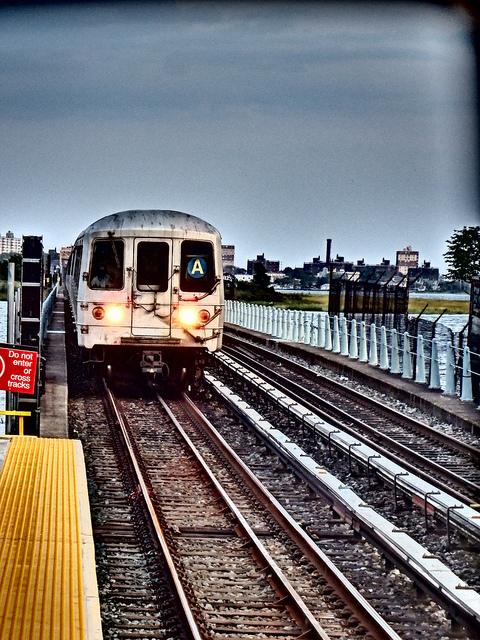Is the train at the station?
Concise answer only. No. What is next to the train?
Keep it brief. Fence. Do you see a small red sign?
Be succinct. Yes. 